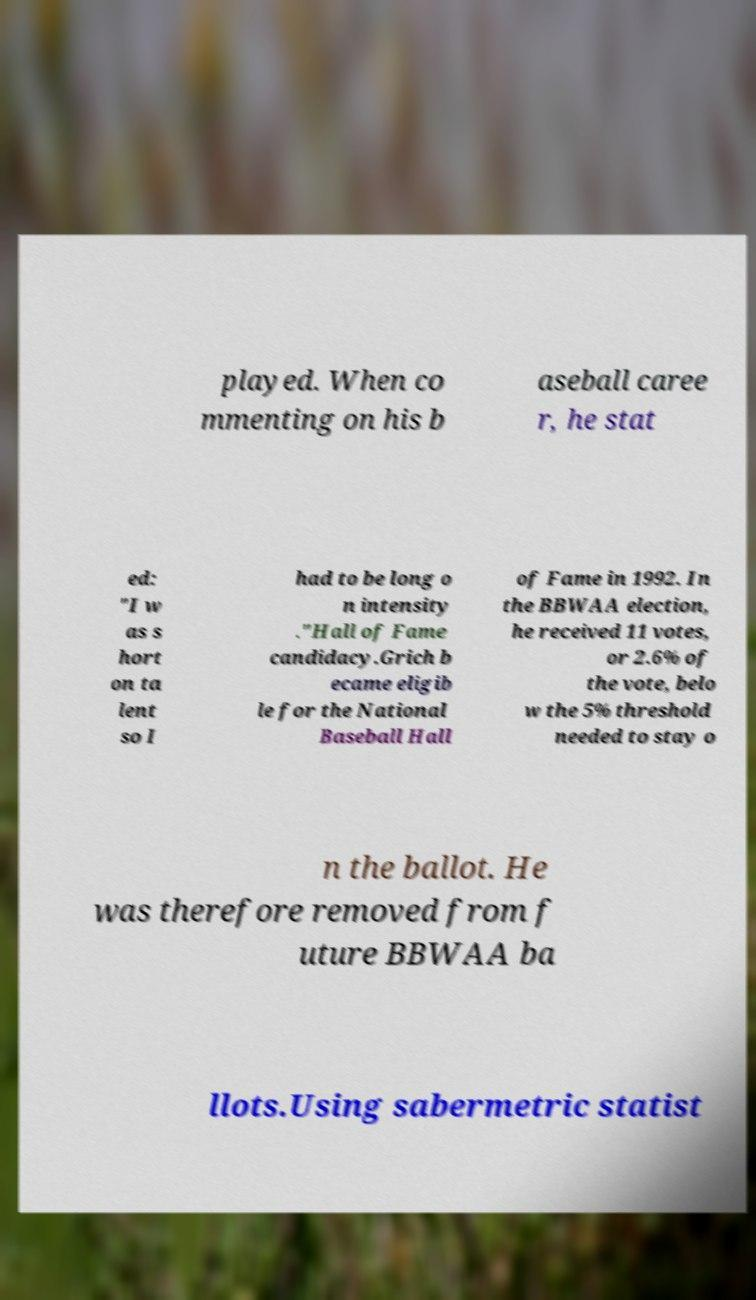There's text embedded in this image that I need extracted. Can you transcribe it verbatim? played. When co mmenting on his b aseball caree r, he stat ed: "I w as s hort on ta lent so I had to be long o n intensity ."Hall of Fame candidacy.Grich b ecame eligib le for the National Baseball Hall of Fame in 1992. In the BBWAA election, he received 11 votes, or 2.6% of the vote, belo w the 5% threshold needed to stay o n the ballot. He was therefore removed from f uture BBWAA ba llots.Using sabermetric statist 